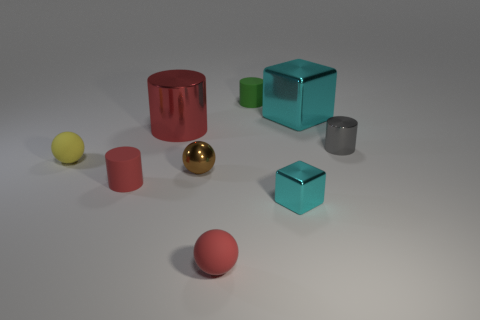What number of objects are small shiny things behind the yellow sphere or big purple things?
Your response must be concise. 1. Is the number of small rubber things on the left side of the small brown ball greater than the number of tiny metal spheres on the right side of the small green rubber thing?
Provide a short and direct response. Yes. Is the material of the green cylinder the same as the small cyan thing?
Provide a short and direct response. No. There is a metal thing that is on the right side of the tiny cube and in front of the big cyan object; what shape is it?
Provide a succinct answer. Cylinder. There is a red thing that is made of the same material as the big cube; what is its shape?
Offer a very short reply. Cylinder. Are any brown things visible?
Your answer should be very brief. Yes. There is a cylinder that is to the right of the green matte thing; are there any red shiny things that are in front of it?
Offer a very short reply. No. There is a large object that is the same shape as the tiny green matte object; what is it made of?
Give a very brief answer. Metal. Are there more rubber cylinders than small balls?
Provide a succinct answer. No. There is a large metallic block; is it the same color as the tiny rubber cylinder on the right side of the small brown thing?
Your response must be concise. No. 